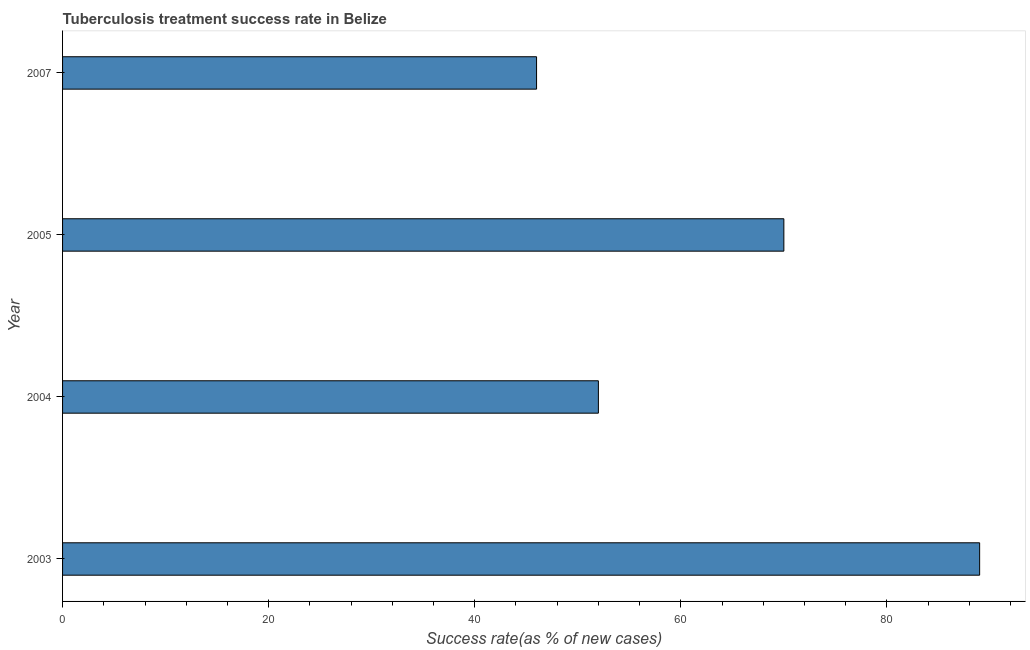Does the graph contain any zero values?
Make the answer very short. No. Does the graph contain grids?
Your response must be concise. No. What is the title of the graph?
Your answer should be compact. Tuberculosis treatment success rate in Belize. What is the label or title of the X-axis?
Your answer should be very brief. Success rate(as % of new cases). Across all years, what is the maximum tuberculosis treatment success rate?
Offer a terse response. 89. Across all years, what is the minimum tuberculosis treatment success rate?
Offer a very short reply. 46. In which year was the tuberculosis treatment success rate maximum?
Provide a short and direct response. 2003. In which year was the tuberculosis treatment success rate minimum?
Offer a very short reply. 2007. What is the sum of the tuberculosis treatment success rate?
Provide a succinct answer. 257. What is the difference between the tuberculosis treatment success rate in 2003 and 2005?
Offer a terse response. 19. What is the median tuberculosis treatment success rate?
Make the answer very short. 61. In how many years, is the tuberculosis treatment success rate greater than 84 %?
Provide a short and direct response. 1. What is the ratio of the tuberculosis treatment success rate in 2005 to that in 2007?
Keep it short and to the point. 1.52. Is the tuberculosis treatment success rate in 2004 less than that in 2007?
Offer a terse response. No. Is the sum of the tuberculosis treatment success rate in 2004 and 2007 greater than the maximum tuberculosis treatment success rate across all years?
Offer a very short reply. Yes. What is the difference between the highest and the lowest tuberculosis treatment success rate?
Your answer should be very brief. 43. In how many years, is the tuberculosis treatment success rate greater than the average tuberculosis treatment success rate taken over all years?
Offer a terse response. 2. How many bars are there?
Make the answer very short. 4. How many years are there in the graph?
Provide a short and direct response. 4. What is the difference between two consecutive major ticks on the X-axis?
Your response must be concise. 20. Are the values on the major ticks of X-axis written in scientific E-notation?
Keep it short and to the point. No. What is the Success rate(as % of new cases) of 2003?
Offer a terse response. 89. What is the Success rate(as % of new cases) of 2005?
Your response must be concise. 70. What is the Success rate(as % of new cases) in 2007?
Your answer should be very brief. 46. What is the difference between the Success rate(as % of new cases) in 2005 and 2007?
Your response must be concise. 24. What is the ratio of the Success rate(as % of new cases) in 2003 to that in 2004?
Provide a succinct answer. 1.71. What is the ratio of the Success rate(as % of new cases) in 2003 to that in 2005?
Give a very brief answer. 1.27. What is the ratio of the Success rate(as % of new cases) in 2003 to that in 2007?
Keep it short and to the point. 1.94. What is the ratio of the Success rate(as % of new cases) in 2004 to that in 2005?
Ensure brevity in your answer.  0.74. What is the ratio of the Success rate(as % of new cases) in 2004 to that in 2007?
Give a very brief answer. 1.13. What is the ratio of the Success rate(as % of new cases) in 2005 to that in 2007?
Provide a short and direct response. 1.52. 